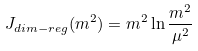<formula> <loc_0><loc_0><loc_500><loc_500>J _ { d i m - r e g } ( m ^ { 2 } ) = m ^ { 2 } \ln { \frac { m ^ { 2 } } { \mu ^ { 2 } } }</formula> 